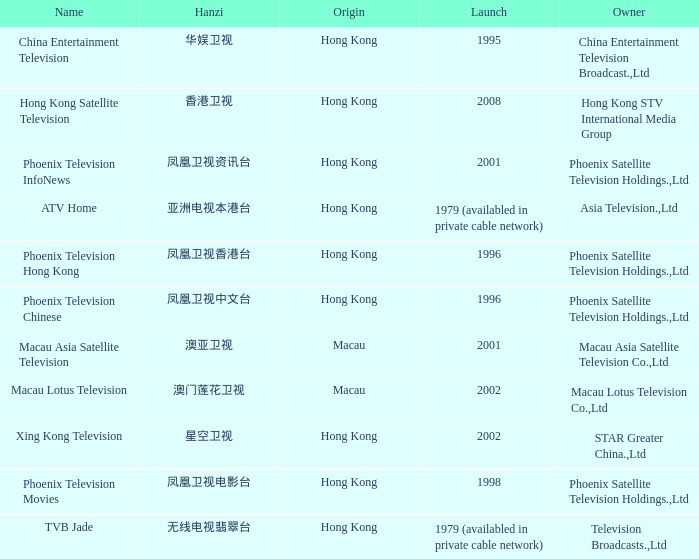Where did the Hanzi of 凤凰卫视电影台 originate? Hong Kong. 